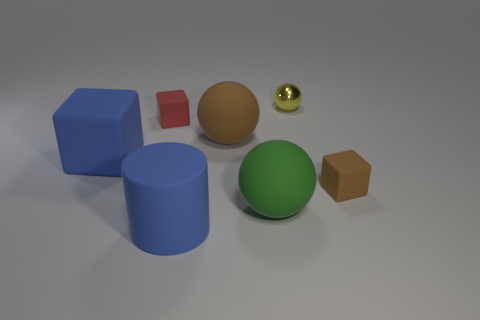Add 3 tiny yellow rubber objects. How many objects exist? 10 Subtract all matte spheres. How many spheres are left? 1 Subtract all blocks. How many objects are left? 4 Subtract 1 blue cylinders. How many objects are left? 6 Subtract all cyan spheres. Subtract all blue cylinders. How many spheres are left? 3 Subtract all tiny red rubber blocks. Subtract all large yellow matte spheres. How many objects are left? 6 Add 3 big blue cubes. How many big blue cubes are left? 4 Add 2 yellow things. How many yellow things exist? 3 